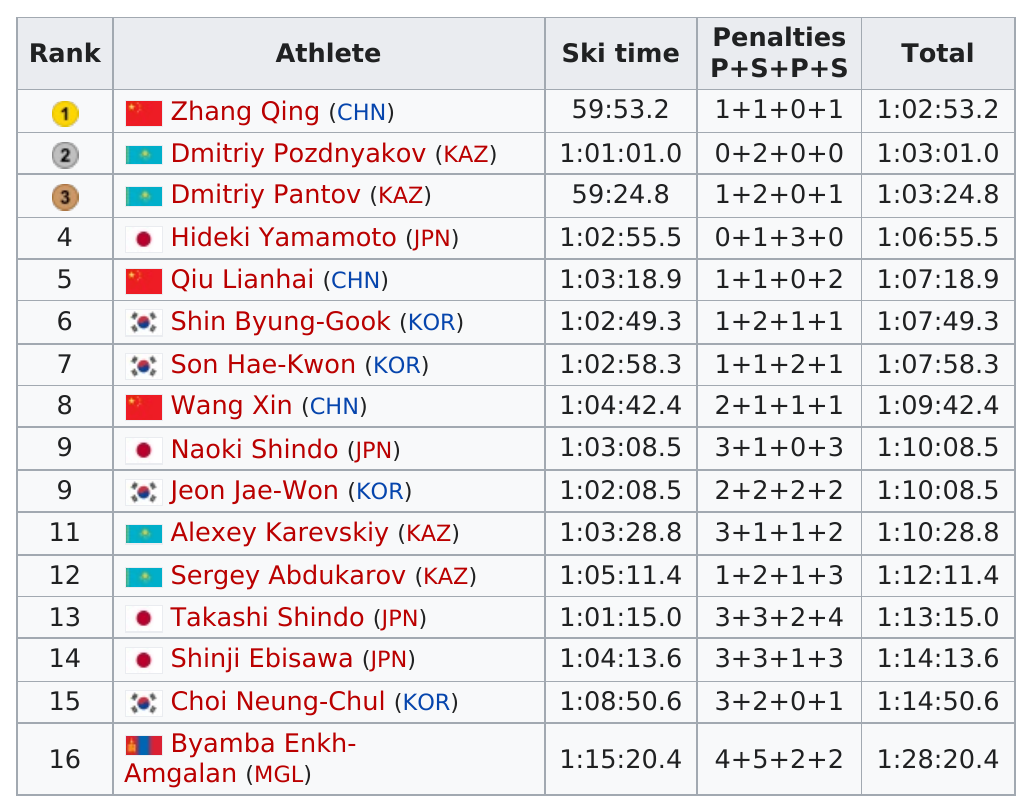Point out several critical features in this image. Hideki Yamamoto received the top time for Japan. Four Japanese athletes finished the race with a total time less than 1:10:00. The highest amount of penalty points was by Byamba Enkh-Amgalan (MGL). Wang Xin was ranked below Qiu Lianghai. China had three athletes in the top 10 ranks. 